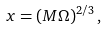<formula> <loc_0><loc_0><loc_500><loc_500>x = ( M \Omega ) ^ { 2 / 3 } \, ,</formula> 